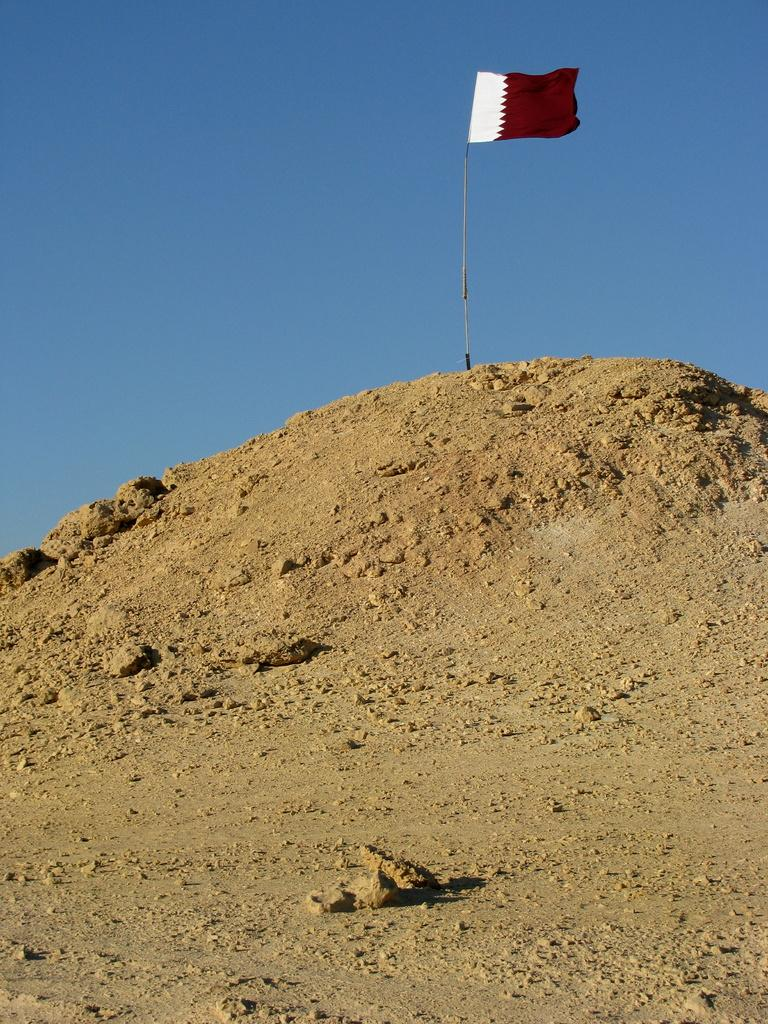What is the main object in the image? There is a flag in the image. What colors are present on the flag? The flag is brown and white in color. Where is the flag located? The flag is placed on top of a hill. What can be seen at the top of the image? The sky is visible at the top of the image. What is the color of the sky in the image? The sky is blue in color. How many rabbits are sitting on the furniture in the image? There are no rabbits or furniture present in the image. 